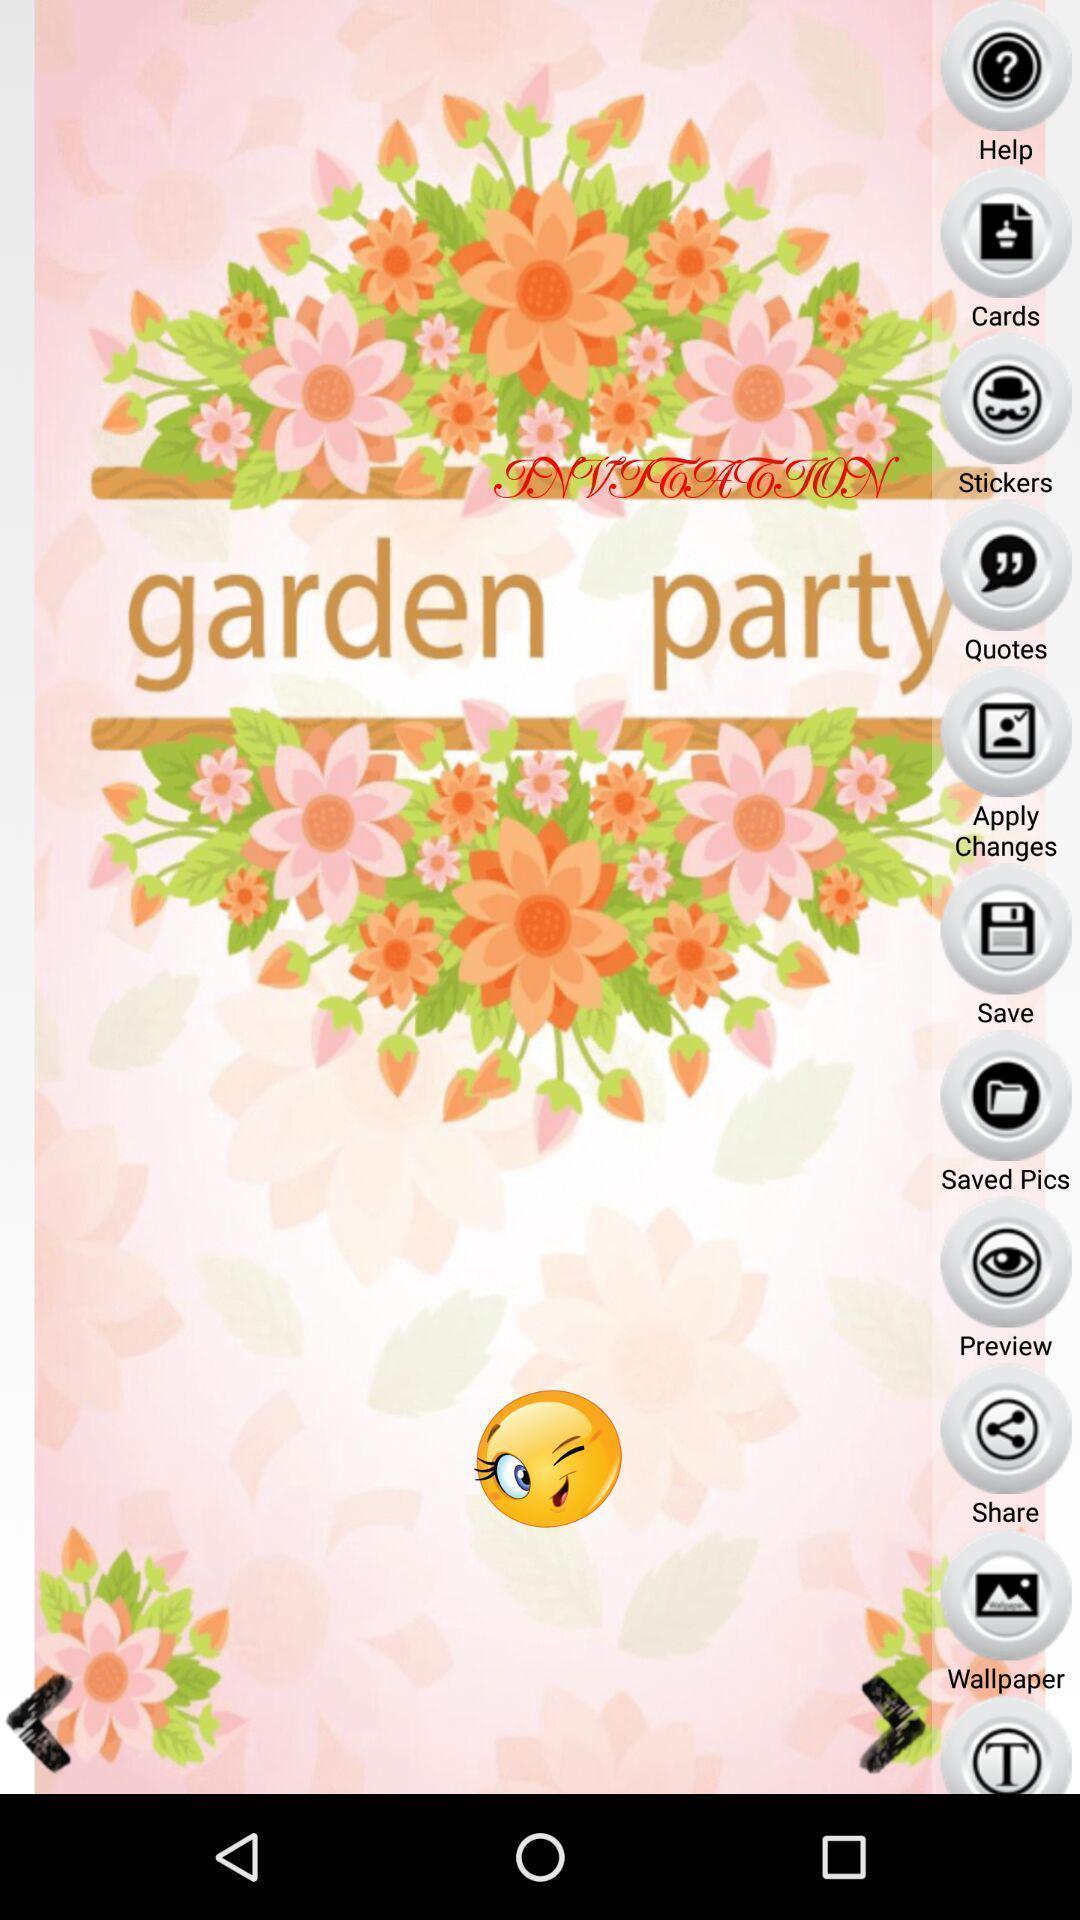Explain what's happening in this screen capture. Welcome page of a card making app. 